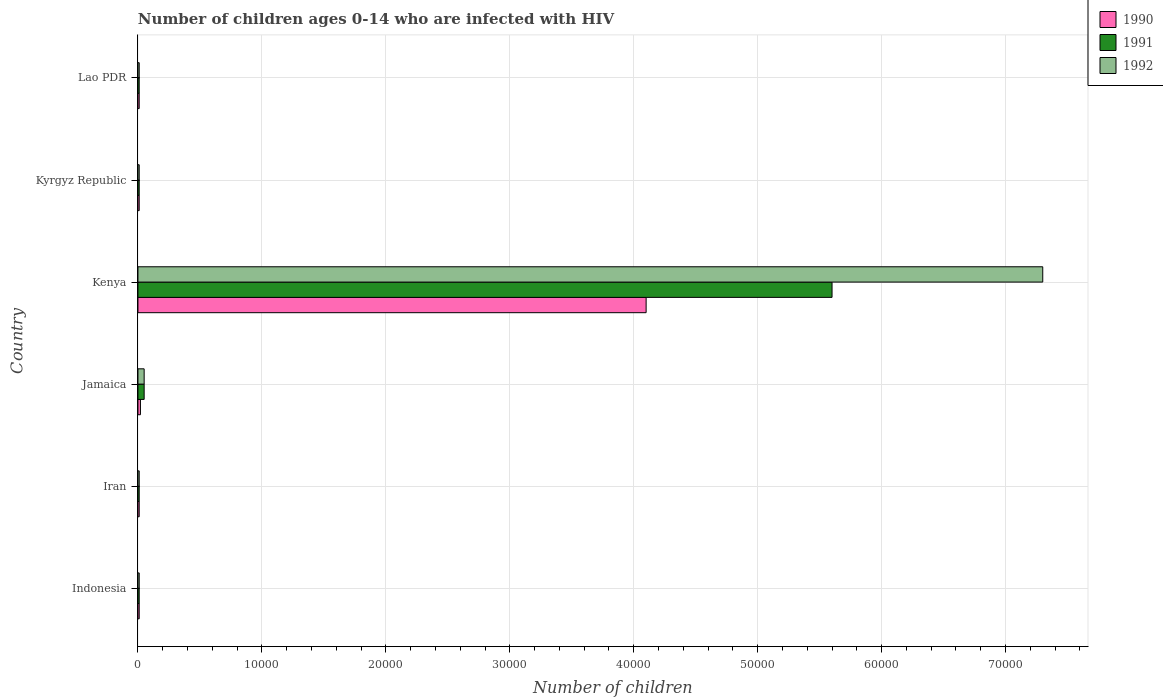How many different coloured bars are there?
Provide a succinct answer. 3. Are the number of bars per tick equal to the number of legend labels?
Your answer should be compact. Yes. Are the number of bars on each tick of the Y-axis equal?
Your answer should be compact. Yes. How many bars are there on the 4th tick from the bottom?
Give a very brief answer. 3. What is the label of the 1st group of bars from the top?
Keep it short and to the point. Lao PDR. In how many cases, is the number of bars for a given country not equal to the number of legend labels?
Offer a very short reply. 0. What is the number of HIV infected children in 1992 in Kenya?
Offer a very short reply. 7.30e+04. Across all countries, what is the maximum number of HIV infected children in 1991?
Offer a very short reply. 5.60e+04. Across all countries, what is the minimum number of HIV infected children in 1992?
Offer a terse response. 100. In which country was the number of HIV infected children in 1991 maximum?
Ensure brevity in your answer.  Kenya. In which country was the number of HIV infected children in 1992 minimum?
Provide a short and direct response. Indonesia. What is the total number of HIV infected children in 1990 in the graph?
Ensure brevity in your answer.  4.16e+04. What is the difference between the number of HIV infected children in 1991 in Jamaica and that in Lao PDR?
Offer a very short reply. 400. What is the difference between the number of HIV infected children in 1990 in Lao PDR and the number of HIV infected children in 1991 in Indonesia?
Make the answer very short. 0. What is the average number of HIV infected children in 1990 per country?
Offer a terse response. 6933.33. In how many countries, is the number of HIV infected children in 1992 greater than 8000 ?
Your answer should be very brief. 1. What is the ratio of the number of HIV infected children in 1990 in Kenya to that in Kyrgyz Republic?
Ensure brevity in your answer.  410. Is the number of HIV infected children in 1990 in Jamaica less than that in Lao PDR?
Ensure brevity in your answer.  No. What is the difference between the highest and the second highest number of HIV infected children in 1991?
Your answer should be compact. 5.55e+04. What is the difference between the highest and the lowest number of HIV infected children in 1991?
Make the answer very short. 5.59e+04. Is the sum of the number of HIV infected children in 1990 in Iran and Jamaica greater than the maximum number of HIV infected children in 1991 across all countries?
Offer a very short reply. No. What does the 2nd bar from the top in Lao PDR represents?
Provide a short and direct response. 1991. How many bars are there?
Provide a short and direct response. 18. Does the graph contain any zero values?
Your answer should be very brief. No. How many legend labels are there?
Offer a terse response. 3. How are the legend labels stacked?
Give a very brief answer. Vertical. What is the title of the graph?
Offer a very short reply. Number of children ages 0-14 who are infected with HIV. Does "1973" appear as one of the legend labels in the graph?
Your answer should be very brief. No. What is the label or title of the X-axis?
Your answer should be very brief. Number of children. What is the label or title of the Y-axis?
Ensure brevity in your answer.  Country. What is the Number of children of 1990 in Indonesia?
Provide a succinct answer. 100. What is the Number of children of 1991 in Iran?
Offer a terse response. 100. What is the Number of children in 1990 in Jamaica?
Ensure brevity in your answer.  200. What is the Number of children in 1992 in Jamaica?
Your answer should be very brief. 500. What is the Number of children in 1990 in Kenya?
Offer a terse response. 4.10e+04. What is the Number of children of 1991 in Kenya?
Keep it short and to the point. 5.60e+04. What is the Number of children of 1992 in Kenya?
Keep it short and to the point. 7.30e+04. What is the Number of children in 1990 in Kyrgyz Republic?
Keep it short and to the point. 100. What is the Number of children in 1991 in Kyrgyz Republic?
Offer a very short reply. 100. What is the Number of children of 1992 in Lao PDR?
Provide a short and direct response. 100. Across all countries, what is the maximum Number of children in 1990?
Give a very brief answer. 4.10e+04. Across all countries, what is the maximum Number of children in 1991?
Keep it short and to the point. 5.60e+04. Across all countries, what is the maximum Number of children in 1992?
Keep it short and to the point. 7.30e+04. Across all countries, what is the minimum Number of children in 1991?
Your response must be concise. 100. What is the total Number of children in 1990 in the graph?
Ensure brevity in your answer.  4.16e+04. What is the total Number of children of 1991 in the graph?
Offer a very short reply. 5.69e+04. What is the total Number of children in 1992 in the graph?
Make the answer very short. 7.39e+04. What is the difference between the Number of children in 1990 in Indonesia and that in Iran?
Provide a short and direct response. 0. What is the difference between the Number of children of 1990 in Indonesia and that in Jamaica?
Make the answer very short. -100. What is the difference between the Number of children of 1991 in Indonesia and that in Jamaica?
Ensure brevity in your answer.  -400. What is the difference between the Number of children of 1992 in Indonesia and that in Jamaica?
Ensure brevity in your answer.  -400. What is the difference between the Number of children of 1990 in Indonesia and that in Kenya?
Provide a short and direct response. -4.09e+04. What is the difference between the Number of children in 1991 in Indonesia and that in Kenya?
Provide a short and direct response. -5.59e+04. What is the difference between the Number of children in 1992 in Indonesia and that in Kenya?
Your answer should be compact. -7.29e+04. What is the difference between the Number of children in 1990 in Indonesia and that in Kyrgyz Republic?
Make the answer very short. 0. What is the difference between the Number of children of 1992 in Indonesia and that in Kyrgyz Republic?
Provide a succinct answer. 0. What is the difference between the Number of children of 1990 in Indonesia and that in Lao PDR?
Your answer should be very brief. 0. What is the difference between the Number of children of 1990 in Iran and that in Jamaica?
Your answer should be very brief. -100. What is the difference between the Number of children in 1991 in Iran and that in Jamaica?
Offer a terse response. -400. What is the difference between the Number of children in 1992 in Iran and that in Jamaica?
Offer a terse response. -400. What is the difference between the Number of children of 1990 in Iran and that in Kenya?
Provide a succinct answer. -4.09e+04. What is the difference between the Number of children of 1991 in Iran and that in Kenya?
Ensure brevity in your answer.  -5.59e+04. What is the difference between the Number of children of 1992 in Iran and that in Kenya?
Keep it short and to the point. -7.29e+04. What is the difference between the Number of children in 1990 in Iran and that in Kyrgyz Republic?
Your answer should be very brief. 0. What is the difference between the Number of children of 1991 in Iran and that in Kyrgyz Republic?
Provide a succinct answer. 0. What is the difference between the Number of children in 1992 in Iran and that in Kyrgyz Republic?
Offer a very short reply. 0. What is the difference between the Number of children of 1990 in Jamaica and that in Kenya?
Make the answer very short. -4.08e+04. What is the difference between the Number of children of 1991 in Jamaica and that in Kenya?
Make the answer very short. -5.55e+04. What is the difference between the Number of children in 1992 in Jamaica and that in Kenya?
Offer a terse response. -7.25e+04. What is the difference between the Number of children of 1991 in Jamaica and that in Kyrgyz Republic?
Keep it short and to the point. 400. What is the difference between the Number of children of 1992 in Jamaica and that in Kyrgyz Republic?
Ensure brevity in your answer.  400. What is the difference between the Number of children of 1990 in Jamaica and that in Lao PDR?
Your response must be concise. 100. What is the difference between the Number of children of 1990 in Kenya and that in Kyrgyz Republic?
Ensure brevity in your answer.  4.09e+04. What is the difference between the Number of children in 1991 in Kenya and that in Kyrgyz Republic?
Keep it short and to the point. 5.59e+04. What is the difference between the Number of children of 1992 in Kenya and that in Kyrgyz Republic?
Provide a short and direct response. 7.29e+04. What is the difference between the Number of children of 1990 in Kenya and that in Lao PDR?
Keep it short and to the point. 4.09e+04. What is the difference between the Number of children in 1991 in Kenya and that in Lao PDR?
Keep it short and to the point. 5.59e+04. What is the difference between the Number of children of 1992 in Kenya and that in Lao PDR?
Make the answer very short. 7.29e+04. What is the difference between the Number of children of 1992 in Kyrgyz Republic and that in Lao PDR?
Your answer should be very brief. 0. What is the difference between the Number of children of 1990 in Indonesia and the Number of children of 1991 in Iran?
Give a very brief answer. 0. What is the difference between the Number of children in 1990 in Indonesia and the Number of children in 1992 in Iran?
Make the answer very short. 0. What is the difference between the Number of children of 1991 in Indonesia and the Number of children of 1992 in Iran?
Make the answer very short. 0. What is the difference between the Number of children in 1990 in Indonesia and the Number of children in 1991 in Jamaica?
Offer a very short reply. -400. What is the difference between the Number of children of 1990 in Indonesia and the Number of children of 1992 in Jamaica?
Make the answer very short. -400. What is the difference between the Number of children in 1991 in Indonesia and the Number of children in 1992 in Jamaica?
Your answer should be very brief. -400. What is the difference between the Number of children in 1990 in Indonesia and the Number of children in 1991 in Kenya?
Offer a very short reply. -5.59e+04. What is the difference between the Number of children of 1990 in Indonesia and the Number of children of 1992 in Kenya?
Give a very brief answer. -7.29e+04. What is the difference between the Number of children of 1991 in Indonesia and the Number of children of 1992 in Kenya?
Give a very brief answer. -7.29e+04. What is the difference between the Number of children of 1990 in Indonesia and the Number of children of 1991 in Lao PDR?
Offer a very short reply. 0. What is the difference between the Number of children in 1990 in Iran and the Number of children in 1991 in Jamaica?
Your answer should be compact. -400. What is the difference between the Number of children of 1990 in Iran and the Number of children of 1992 in Jamaica?
Make the answer very short. -400. What is the difference between the Number of children of 1991 in Iran and the Number of children of 1992 in Jamaica?
Your answer should be very brief. -400. What is the difference between the Number of children of 1990 in Iran and the Number of children of 1991 in Kenya?
Your response must be concise. -5.59e+04. What is the difference between the Number of children of 1990 in Iran and the Number of children of 1992 in Kenya?
Offer a terse response. -7.29e+04. What is the difference between the Number of children in 1991 in Iran and the Number of children in 1992 in Kenya?
Give a very brief answer. -7.29e+04. What is the difference between the Number of children of 1990 in Iran and the Number of children of 1991 in Kyrgyz Republic?
Your response must be concise. 0. What is the difference between the Number of children in 1990 in Iran and the Number of children in 1992 in Kyrgyz Republic?
Provide a short and direct response. 0. What is the difference between the Number of children in 1991 in Iran and the Number of children in 1992 in Kyrgyz Republic?
Give a very brief answer. 0. What is the difference between the Number of children in 1990 in Iran and the Number of children in 1992 in Lao PDR?
Offer a terse response. 0. What is the difference between the Number of children of 1991 in Iran and the Number of children of 1992 in Lao PDR?
Offer a very short reply. 0. What is the difference between the Number of children of 1990 in Jamaica and the Number of children of 1991 in Kenya?
Give a very brief answer. -5.58e+04. What is the difference between the Number of children of 1990 in Jamaica and the Number of children of 1992 in Kenya?
Your answer should be very brief. -7.28e+04. What is the difference between the Number of children of 1991 in Jamaica and the Number of children of 1992 in Kenya?
Your answer should be very brief. -7.25e+04. What is the difference between the Number of children in 1990 in Jamaica and the Number of children in 1991 in Lao PDR?
Your answer should be compact. 100. What is the difference between the Number of children of 1991 in Jamaica and the Number of children of 1992 in Lao PDR?
Your answer should be very brief. 400. What is the difference between the Number of children of 1990 in Kenya and the Number of children of 1991 in Kyrgyz Republic?
Ensure brevity in your answer.  4.09e+04. What is the difference between the Number of children in 1990 in Kenya and the Number of children in 1992 in Kyrgyz Republic?
Your answer should be compact. 4.09e+04. What is the difference between the Number of children of 1991 in Kenya and the Number of children of 1992 in Kyrgyz Republic?
Offer a terse response. 5.59e+04. What is the difference between the Number of children of 1990 in Kenya and the Number of children of 1991 in Lao PDR?
Ensure brevity in your answer.  4.09e+04. What is the difference between the Number of children of 1990 in Kenya and the Number of children of 1992 in Lao PDR?
Give a very brief answer. 4.09e+04. What is the difference between the Number of children of 1991 in Kenya and the Number of children of 1992 in Lao PDR?
Make the answer very short. 5.59e+04. What is the difference between the Number of children in 1990 in Kyrgyz Republic and the Number of children in 1991 in Lao PDR?
Offer a very short reply. 0. What is the difference between the Number of children in 1990 in Kyrgyz Republic and the Number of children in 1992 in Lao PDR?
Offer a very short reply. 0. What is the difference between the Number of children in 1991 in Kyrgyz Republic and the Number of children in 1992 in Lao PDR?
Ensure brevity in your answer.  0. What is the average Number of children in 1990 per country?
Provide a short and direct response. 6933.33. What is the average Number of children of 1991 per country?
Provide a short and direct response. 9483.33. What is the average Number of children of 1992 per country?
Offer a very short reply. 1.23e+04. What is the difference between the Number of children in 1990 and Number of children in 1992 in Indonesia?
Offer a terse response. 0. What is the difference between the Number of children in 1991 and Number of children in 1992 in Indonesia?
Give a very brief answer. 0. What is the difference between the Number of children in 1990 and Number of children in 1991 in Jamaica?
Give a very brief answer. -300. What is the difference between the Number of children of 1990 and Number of children of 1992 in Jamaica?
Ensure brevity in your answer.  -300. What is the difference between the Number of children of 1990 and Number of children of 1991 in Kenya?
Ensure brevity in your answer.  -1.50e+04. What is the difference between the Number of children in 1990 and Number of children in 1992 in Kenya?
Your response must be concise. -3.20e+04. What is the difference between the Number of children of 1991 and Number of children of 1992 in Kenya?
Give a very brief answer. -1.70e+04. What is the difference between the Number of children of 1990 and Number of children of 1991 in Kyrgyz Republic?
Provide a short and direct response. 0. What is the difference between the Number of children of 1991 and Number of children of 1992 in Kyrgyz Republic?
Ensure brevity in your answer.  0. What is the difference between the Number of children in 1990 and Number of children in 1991 in Lao PDR?
Keep it short and to the point. 0. What is the ratio of the Number of children in 1992 in Indonesia to that in Iran?
Provide a succinct answer. 1. What is the ratio of the Number of children in 1990 in Indonesia to that in Jamaica?
Ensure brevity in your answer.  0.5. What is the ratio of the Number of children in 1991 in Indonesia to that in Jamaica?
Provide a short and direct response. 0.2. What is the ratio of the Number of children in 1990 in Indonesia to that in Kenya?
Keep it short and to the point. 0. What is the ratio of the Number of children of 1991 in Indonesia to that in Kenya?
Give a very brief answer. 0. What is the ratio of the Number of children in 1992 in Indonesia to that in Kenya?
Make the answer very short. 0. What is the ratio of the Number of children in 1990 in Indonesia to that in Kyrgyz Republic?
Provide a succinct answer. 1. What is the ratio of the Number of children of 1991 in Indonesia to that in Kyrgyz Republic?
Ensure brevity in your answer.  1. What is the ratio of the Number of children of 1991 in Indonesia to that in Lao PDR?
Your response must be concise. 1. What is the ratio of the Number of children of 1990 in Iran to that in Jamaica?
Your response must be concise. 0.5. What is the ratio of the Number of children in 1991 in Iran to that in Jamaica?
Your response must be concise. 0.2. What is the ratio of the Number of children of 1992 in Iran to that in Jamaica?
Make the answer very short. 0.2. What is the ratio of the Number of children of 1990 in Iran to that in Kenya?
Give a very brief answer. 0. What is the ratio of the Number of children of 1991 in Iran to that in Kenya?
Give a very brief answer. 0. What is the ratio of the Number of children of 1992 in Iran to that in Kenya?
Make the answer very short. 0. What is the ratio of the Number of children in 1991 in Iran to that in Kyrgyz Republic?
Ensure brevity in your answer.  1. What is the ratio of the Number of children of 1992 in Iran to that in Kyrgyz Republic?
Ensure brevity in your answer.  1. What is the ratio of the Number of children of 1990 in Iran to that in Lao PDR?
Offer a terse response. 1. What is the ratio of the Number of children of 1991 in Iran to that in Lao PDR?
Provide a short and direct response. 1. What is the ratio of the Number of children of 1992 in Iran to that in Lao PDR?
Offer a terse response. 1. What is the ratio of the Number of children in 1990 in Jamaica to that in Kenya?
Make the answer very short. 0. What is the ratio of the Number of children of 1991 in Jamaica to that in Kenya?
Give a very brief answer. 0.01. What is the ratio of the Number of children in 1992 in Jamaica to that in Kenya?
Offer a very short reply. 0.01. What is the ratio of the Number of children of 1991 in Jamaica to that in Kyrgyz Republic?
Ensure brevity in your answer.  5. What is the ratio of the Number of children of 1992 in Jamaica to that in Kyrgyz Republic?
Keep it short and to the point. 5. What is the ratio of the Number of children in 1992 in Jamaica to that in Lao PDR?
Your response must be concise. 5. What is the ratio of the Number of children of 1990 in Kenya to that in Kyrgyz Republic?
Give a very brief answer. 410. What is the ratio of the Number of children of 1991 in Kenya to that in Kyrgyz Republic?
Provide a succinct answer. 560. What is the ratio of the Number of children of 1992 in Kenya to that in Kyrgyz Republic?
Provide a short and direct response. 730. What is the ratio of the Number of children in 1990 in Kenya to that in Lao PDR?
Provide a succinct answer. 410. What is the ratio of the Number of children in 1991 in Kenya to that in Lao PDR?
Give a very brief answer. 560. What is the ratio of the Number of children in 1992 in Kenya to that in Lao PDR?
Offer a very short reply. 730. What is the difference between the highest and the second highest Number of children of 1990?
Make the answer very short. 4.08e+04. What is the difference between the highest and the second highest Number of children in 1991?
Offer a very short reply. 5.55e+04. What is the difference between the highest and the second highest Number of children of 1992?
Your response must be concise. 7.25e+04. What is the difference between the highest and the lowest Number of children of 1990?
Make the answer very short. 4.09e+04. What is the difference between the highest and the lowest Number of children in 1991?
Ensure brevity in your answer.  5.59e+04. What is the difference between the highest and the lowest Number of children of 1992?
Give a very brief answer. 7.29e+04. 